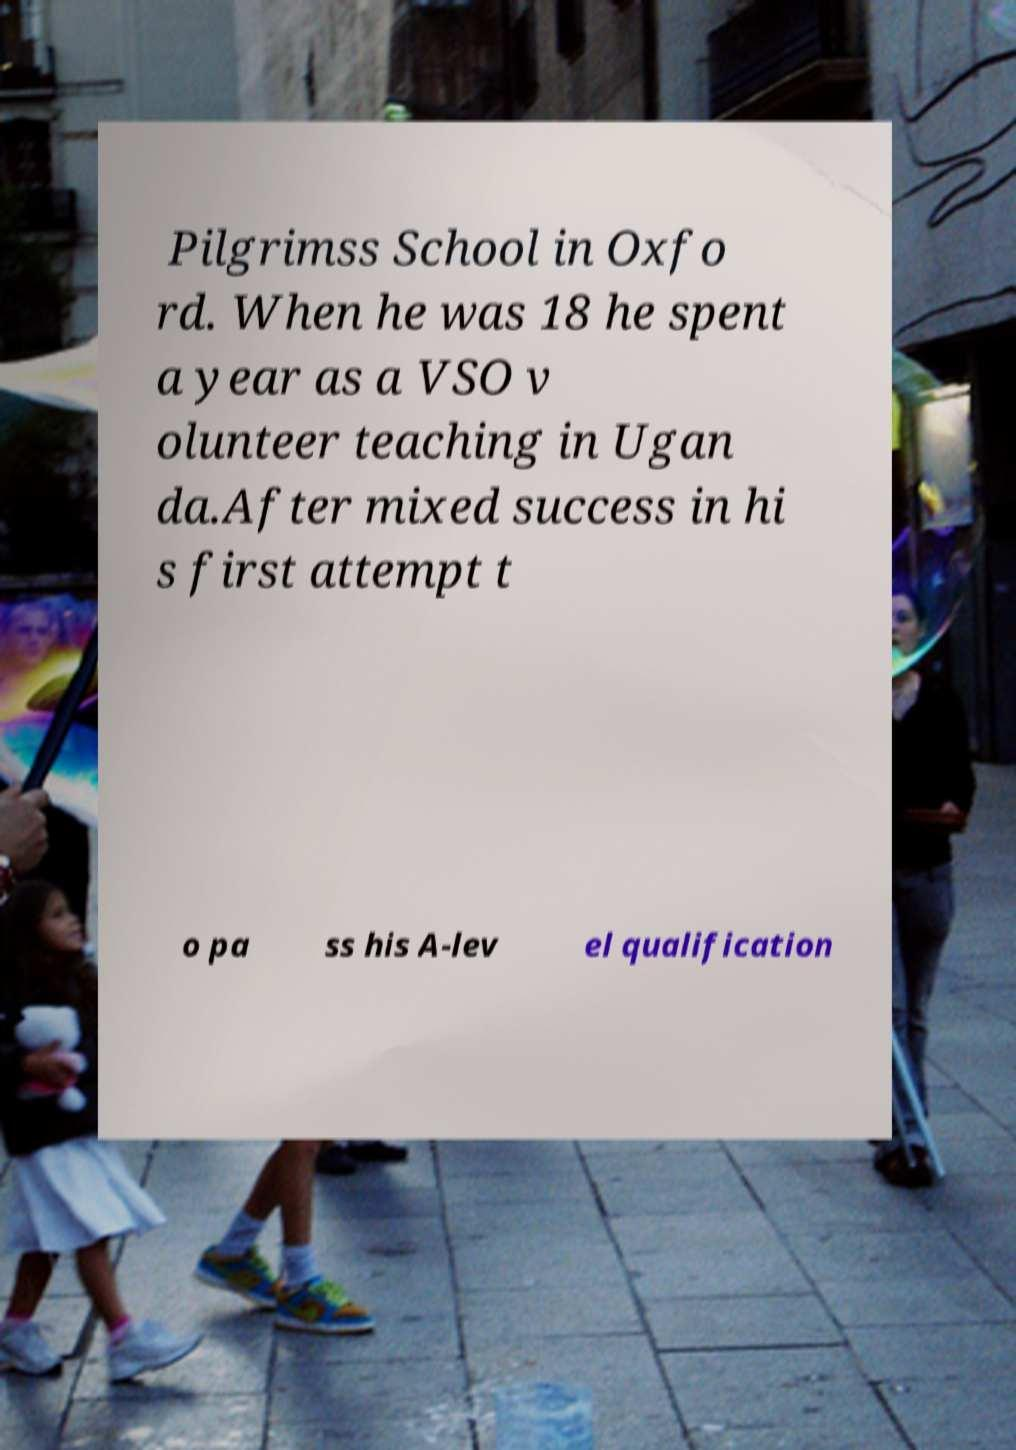I need the written content from this picture converted into text. Can you do that? Pilgrimss School in Oxfo rd. When he was 18 he spent a year as a VSO v olunteer teaching in Ugan da.After mixed success in hi s first attempt t o pa ss his A-lev el qualification 